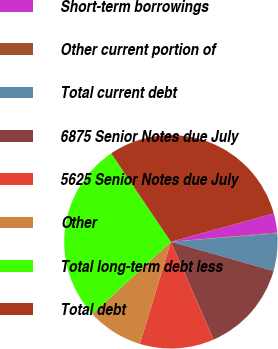Convert chart to OTSL. <chart><loc_0><loc_0><loc_500><loc_500><pie_chart><fcel>Short-term borrowings<fcel>Other current portion of<fcel>Total current debt<fcel>6875 Senior Notes due July<fcel>5625 Senior Notes due July<fcel>Other<fcel>Total long-term debt less<fcel>Total debt<nl><fcel>2.9%<fcel>0.11%<fcel>5.68%<fcel>14.04%<fcel>11.25%<fcel>8.47%<fcel>27.38%<fcel>30.17%<nl></chart> 